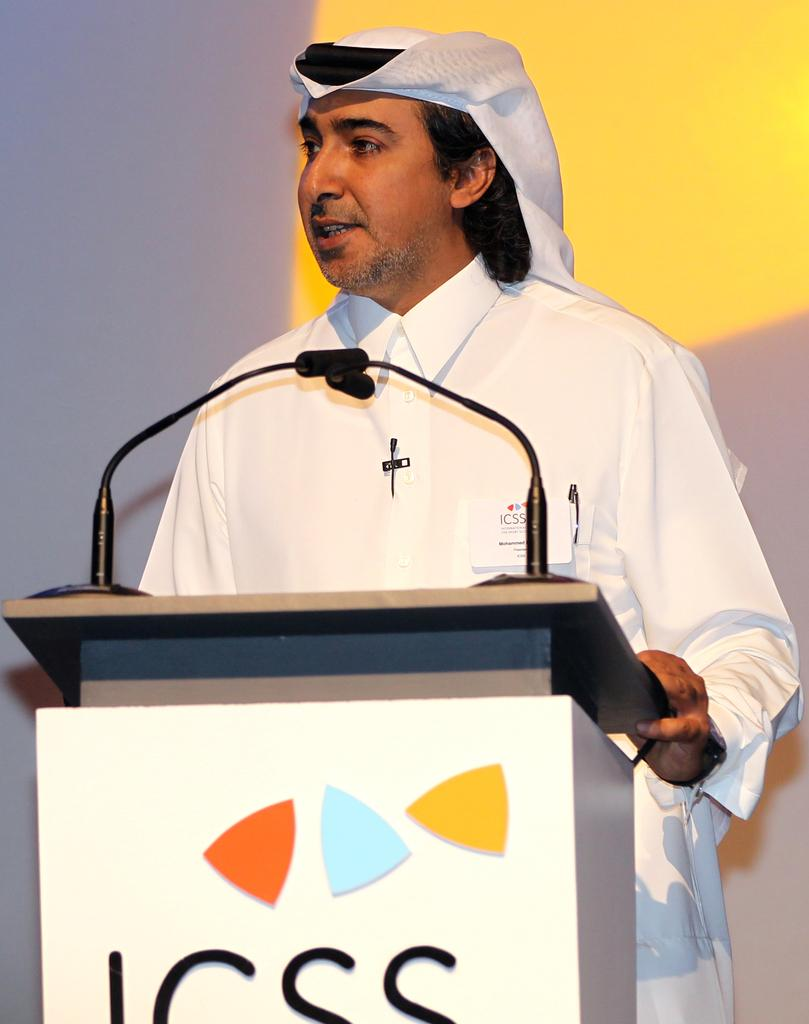What is the main subject of the image? There is a person in the image. Where is the person located in the image? The person is standing on a dais. What is the person doing in the image? The person is speaking. What can be seen in the background of the image? There is mist in the image. What year is depicted in the image? The provided facts do not mention any specific year, so it cannot be determined from the image. Can you tell me what type of quartz is present in the image? There is no quartz present in the image. 